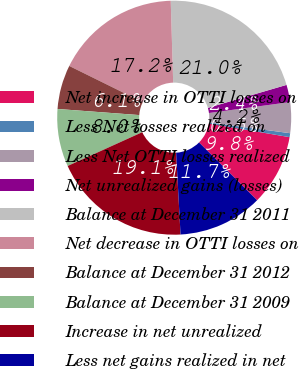Convert chart to OTSL. <chart><loc_0><loc_0><loc_500><loc_500><pie_chart><fcel>Net increase in OTTI losses on<fcel>Less Net losses realized on<fcel>Less Net OTTI losses realized<fcel>Net unrealized gains (losses)<fcel>Balance at December 31 2011<fcel>Net decrease in OTTI losses on<fcel>Balance at December 31 2012<fcel>Balance at December 31 2009<fcel>Increase in net unrealized<fcel>Less net gains realized in net<nl><fcel>9.81%<fcel>0.54%<fcel>4.25%<fcel>2.39%<fcel>20.95%<fcel>17.24%<fcel>6.1%<fcel>7.96%<fcel>19.09%<fcel>11.67%<nl></chart> 